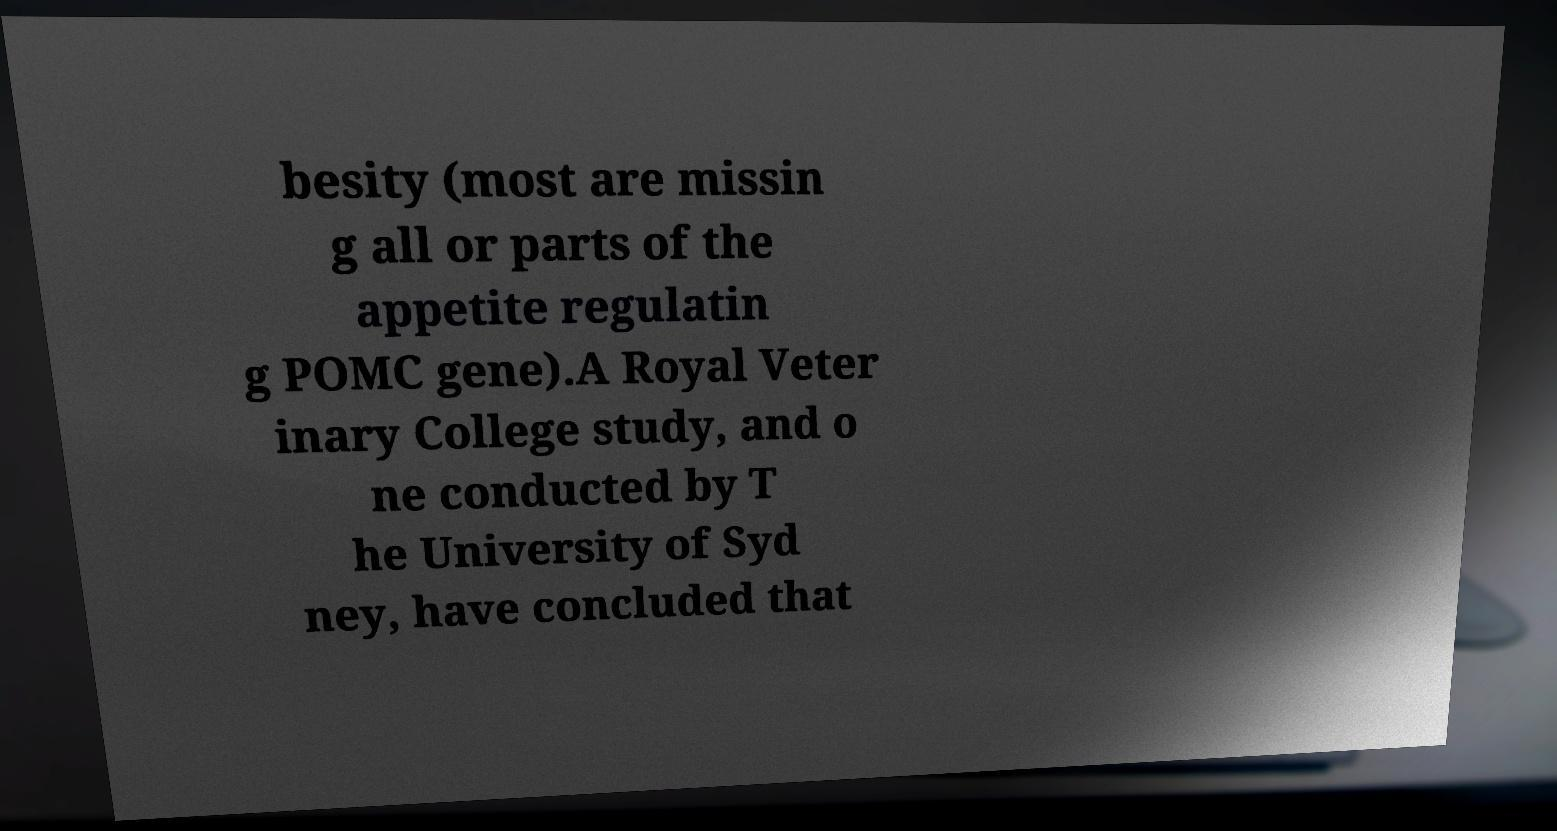Could you extract and type out the text from this image? besity (most are missin g all or parts of the appetite regulatin g POMC gene).A Royal Veter inary College study, and o ne conducted by T he University of Syd ney, have concluded that 